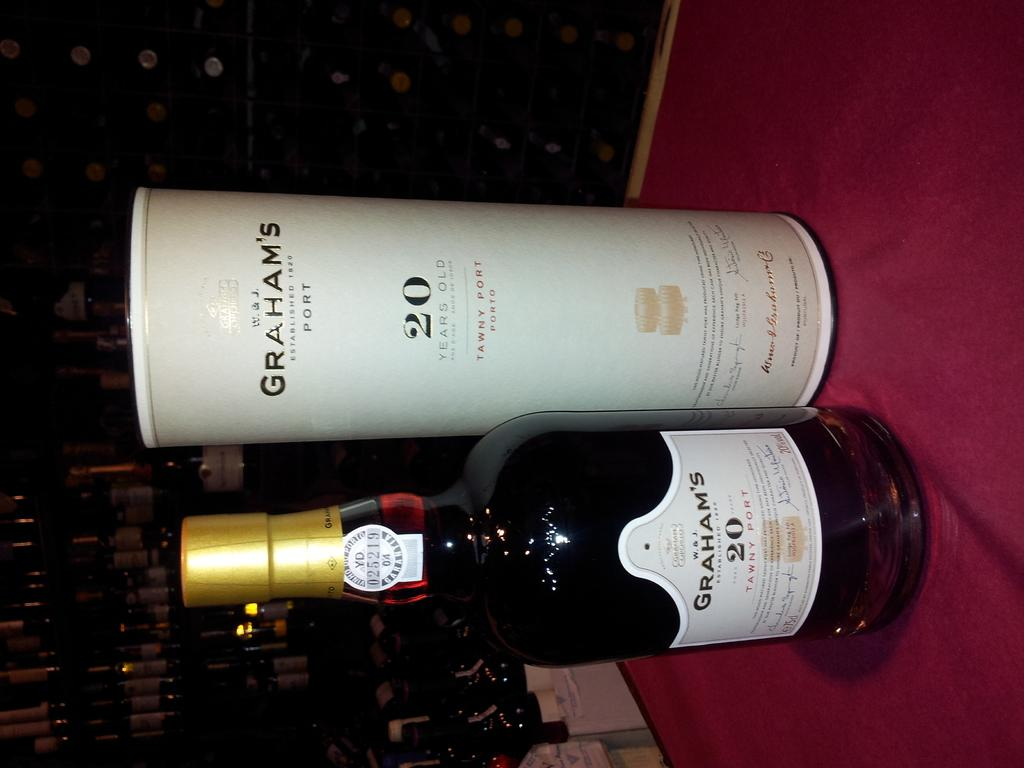<image>
Share a concise interpretation of the image provided. A bottle of Graham's 20 tawny port sits on a red cloth. 